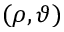Convert formula to latex. <formula><loc_0><loc_0><loc_500><loc_500>( \rho , \vartheta )</formula> 